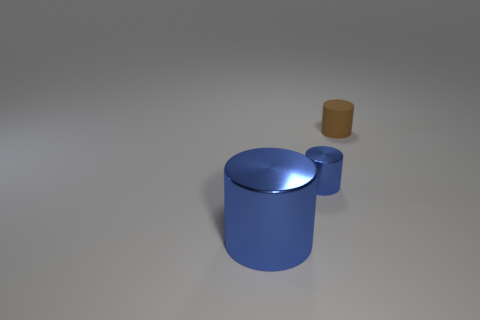There is a metallic thing on the left side of the blue thing on the right side of the big blue metallic thing; what is its size?
Your answer should be compact. Large. What is the size of the object that is both in front of the brown matte cylinder and right of the big blue shiny thing?
Provide a succinct answer. Small. What number of blue metal cylinders are the same size as the rubber object?
Provide a short and direct response. 1. What number of metallic things are brown objects or large cylinders?
Provide a succinct answer. 1. The other thing that is the same color as the tiny shiny object is what size?
Give a very brief answer. Large. The blue cylinder left of the small cylinder that is left of the brown cylinder is made of what material?
Offer a terse response. Metal. How many objects are either big things or blue metal things that are on the right side of the large cylinder?
Offer a very short reply. 2. There is a blue cylinder that is the same material as the tiny blue thing; what is its size?
Give a very brief answer. Large. What number of brown things are cylinders or matte cylinders?
Provide a succinct answer. 1. There is another thing that is the same color as the small metal object; what is its shape?
Give a very brief answer. Cylinder. 